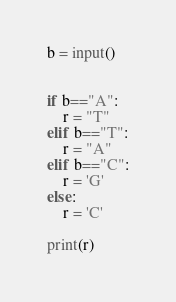Convert code to text. <code><loc_0><loc_0><loc_500><loc_500><_Python_>b = input()


if b=="A":
    r = "T"
elif b=="T":
    r = "A"
elif b=="C":
    r = 'G'
else:
    r = 'C'

print(r)
</code> 